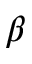<formula> <loc_0><loc_0><loc_500><loc_500>\beta</formula> 